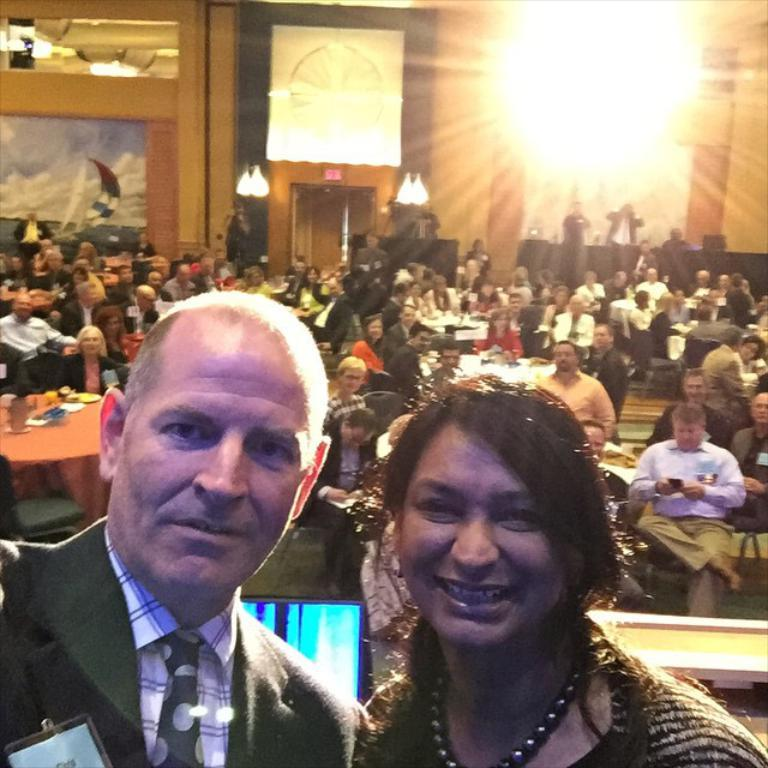What is the main subject of the image? The main subject of the image is a group of people. Can you describe the arrangement of the people in the image? Two people are standing in front of the group. What type of bait is being used by the cat in the image? There is no cat present in the image, and therefore no bait can be observed. 